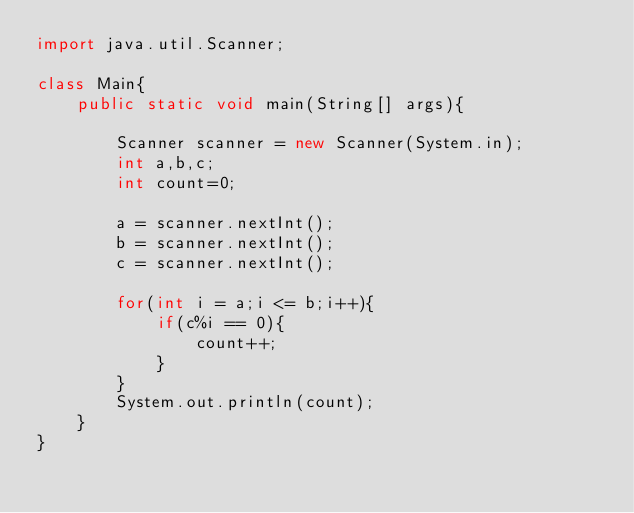Convert code to text. <code><loc_0><loc_0><loc_500><loc_500><_Java_>import java.util.Scanner;

class Main{
    public static void main(String[] args){
        
        Scanner scanner = new Scanner(System.in);
        int a,b,c;
        int count=0;
        
        a = scanner.nextInt();
        b = scanner.nextInt();
        c = scanner.nextInt();
        
        for(int i = a;i <= b;i++){
            if(c%i == 0){
                count++;
            }
        }
        System.out.println(count);
    }
}
</code> 